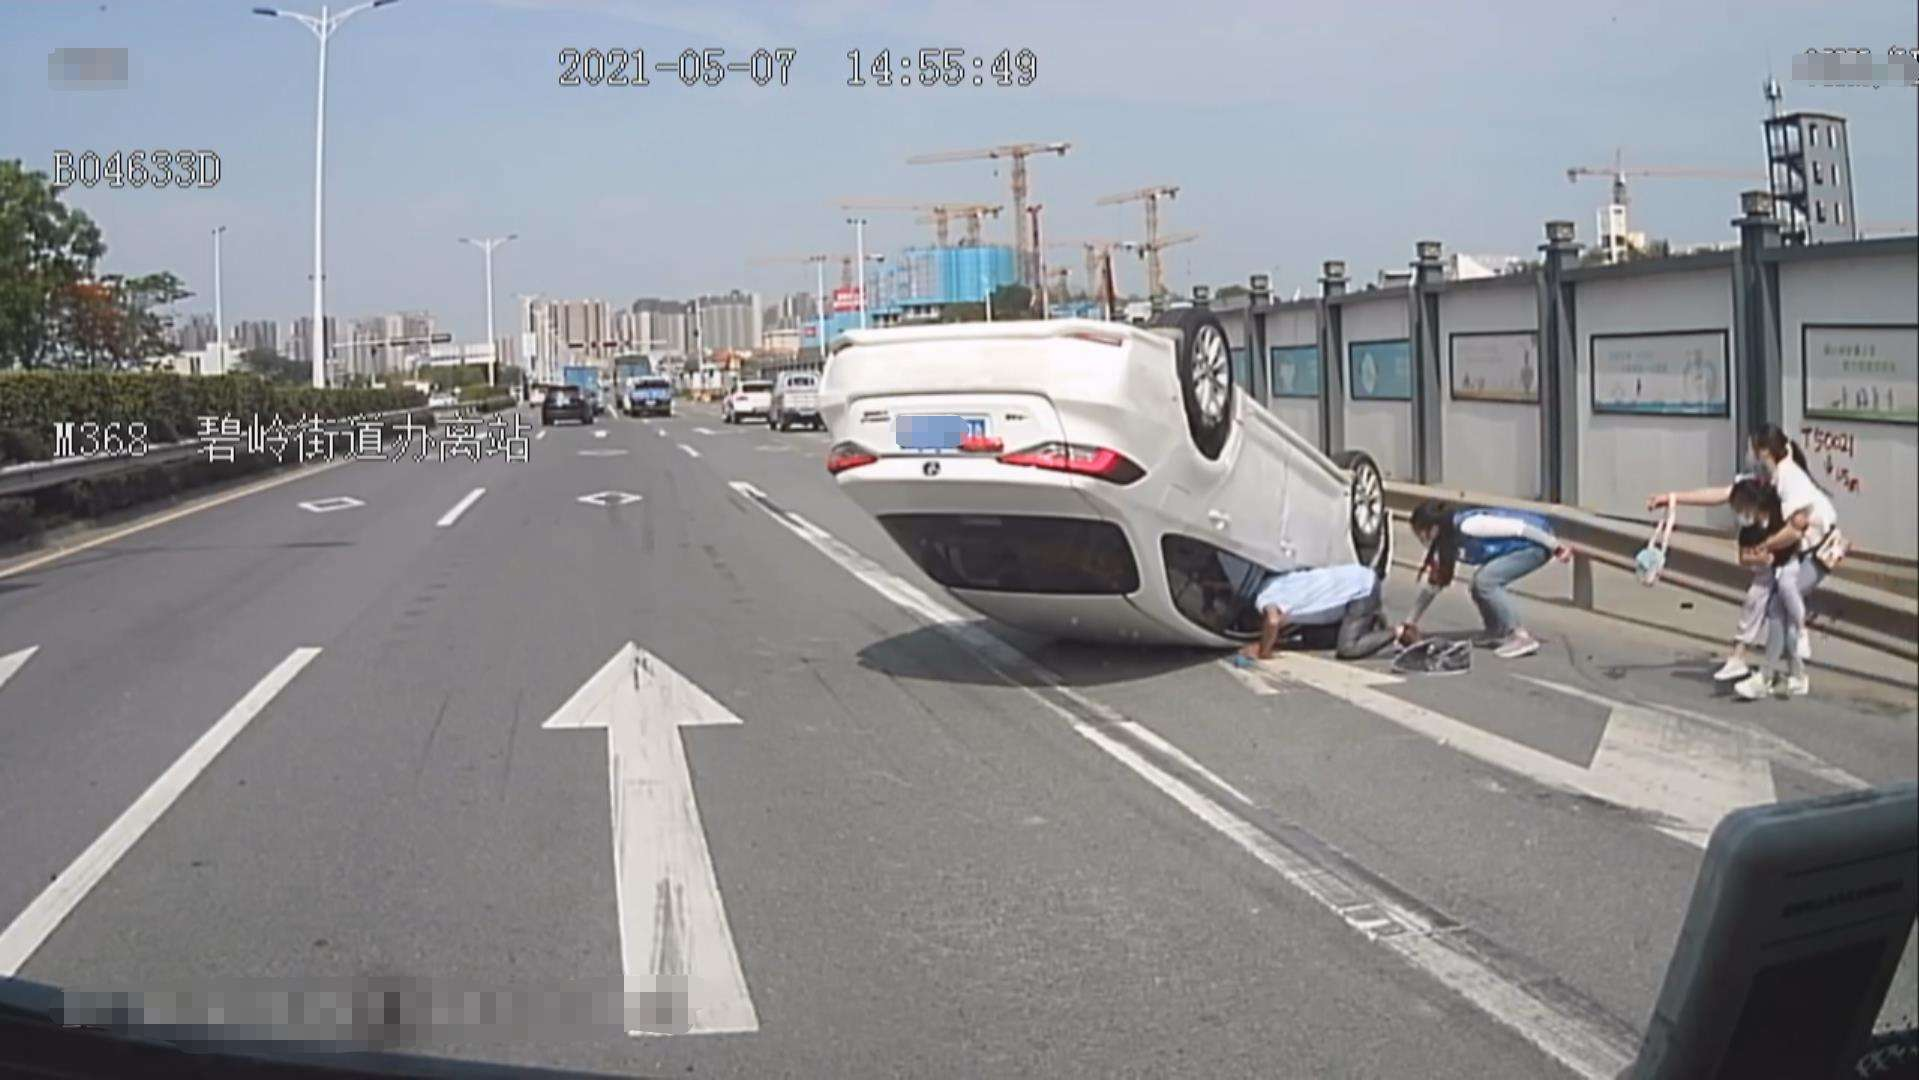How many cars are there in the image? It appears that there is only one car visible in the image. It is a white vehicle that has been overturned in what seems to be an accident. There are also several individuals present around the car, potentially attending to the situation. 